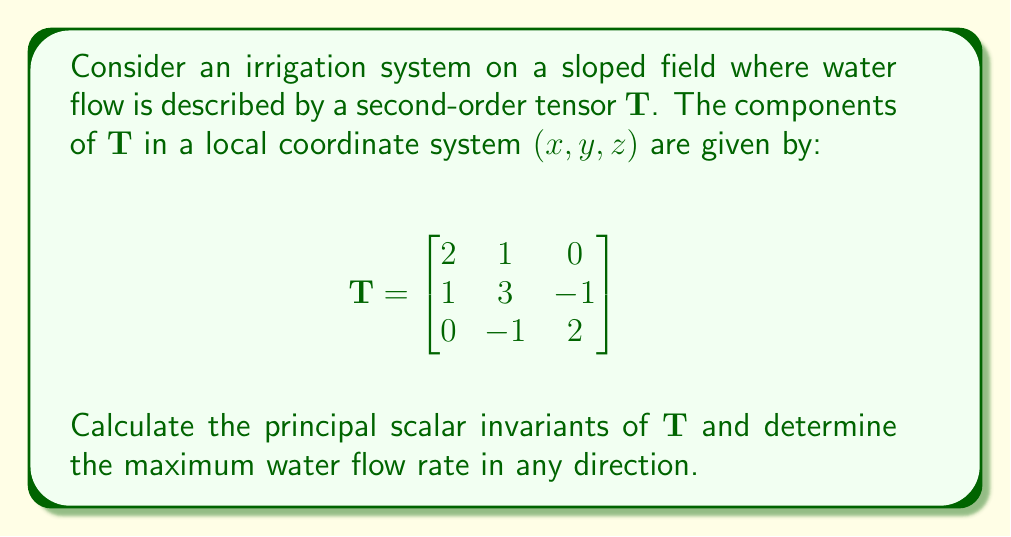Solve this math problem. To solve this problem, we'll follow these steps:

1) First, let's recall that for a 3x3 tensor, the principal scalar invariants are given by:
   
   $I_1 = tr(\mathbf{T})$
   $I_2 = \frac{1}{2}[(tr(\mathbf{T}))^2 - tr(\mathbf{T}^2)]$
   $I_3 = det(\mathbf{T})$

2) Calculate $I_1$:
   $I_1 = tr(\mathbf{T}) = 2 + 3 + 2 = 7$

3) Calculate $I_2$:
   First, we need $tr(\mathbf{T}^2)$:
   
   $$\mathbf{T}^2 = \begin{bmatrix}
   2 & 1 & 0 \\
   1 & 3 & -1 \\
   0 & -1 & 2
   \end{bmatrix} \begin{bmatrix}
   2 & 1 & 0 \\
   1 & 3 & -1 \\
   0 & -1 & 2
   \end{bmatrix} = \begin{bmatrix}
   5 & 5 & -1 \\
   5 & 11 & -4 \\
   -1 & -4 & 5
   \end{bmatrix}$$

   $tr(\mathbf{T}^2) = 5 + 11 + 5 = 21$

   Now we can calculate $I_2$:
   $I_2 = \frac{1}{2}[(7)^2 - 21] = \frac{1}{2}[49 - 21] = 14$

4) Calculate $I_3$:
   $I_3 = det(\mathbf{T}) = 2(3(2) - (-1)(-1)) - 1(1(2) - 0(-1)) + 0(1(-1) - 3(0)) = 2(6-1) - 1(2) = 10 - 2 = 8$

5) To determine the maximum water flow rate, we need to find the largest eigenvalue of $\mathbf{T}$. The characteristic equation is:

   $det(\mathbf{T} - \lambda\mathbf{I}) = 0$

   $-\lambda^3 + 7\lambda^2 - 14\lambda + 8 = 0$

   This is equivalent to:

   $-(\lambda - 1)(\lambda - 2)(\lambda - 4) = 0$

   Therefore, the eigenvalues are 1, 2, and 4.

6) The maximum water flow rate in any direction is given by the largest eigenvalue, which is 4.
Answer: $I_1 = 7$, $I_2 = 14$, $I_3 = 8$, Maximum flow rate = 4 